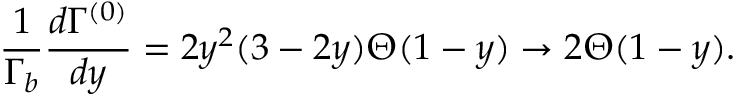Convert formula to latex. <formula><loc_0><loc_0><loc_500><loc_500>\frac { 1 } { \Gamma _ { b } } \frac { d \Gamma ^ { ( 0 ) } } { d y } = 2 y ^ { 2 } ( 3 - 2 y ) \Theta ( 1 - y ) \to 2 \Theta ( 1 - y ) .</formula> 